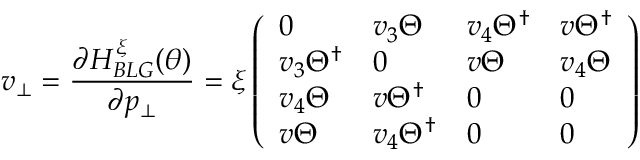<formula> <loc_0><loc_0><loc_500><loc_500>v _ { \bot } = \frac { \partial H _ { B L G } ^ { \xi } ( \theta ) } { \partial p _ { \bot } } = \xi \left ( \begin{array} { l l l l } { 0 } & { v _ { 3 } \Theta } & { v _ { 4 } \Theta ^ { \dagger } } & { v \Theta ^ { \dagger } } \\ { v _ { 3 } \Theta ^ { \dagger } } & { 0 } & { v \Theta } & { v _ { 4 } \Theta } \\ { v _ { 4 } \Theta } & { v \Theta ^ { \dagger } } & { 0 } & { 0 } \\ { v \Theta } & { v _ { 4 } \Theta ^ { \dagger } } & { 0 } & { 0 } \end{array} \right )</formula> 